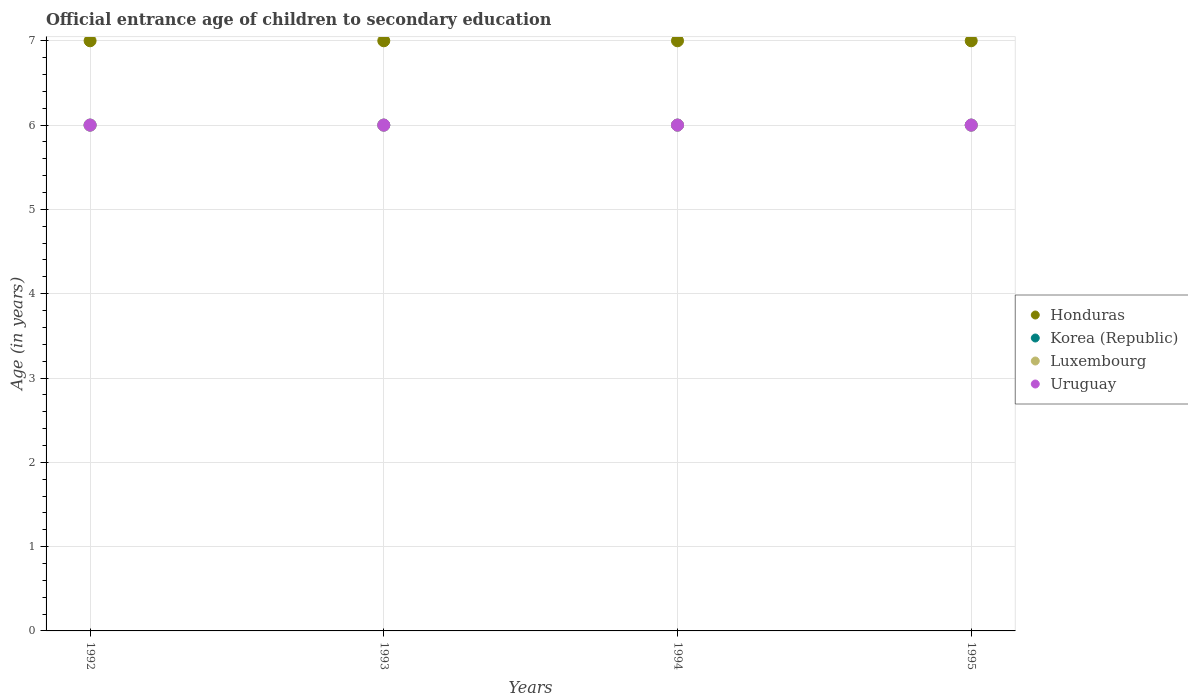How many different coloured dotlines are there?
Your answer should be very brief. 4. What is the secondary school starting age of children in Luxembourg in 1992?
Offer a very short reply. 6. Across all years, what is the maximum secondary school starting age of children in Uruguay?
Make the answer very short. 6. In which year was the secondary school starting age of children in Luxembourg maximum?
Offer a very short reply. 1992. What is the total secondary school starting age of children in Honduras in the graph?
Give a very brief answer. 28. What is the difference between the secondary school starting age of children in Luxembourg in 1992 and that in 1994?
Keep it short and to the point. 0. In the year 1995, what is the difference between the secondary school starting age of children in Korea (Republic) and secondary school starting age of children in Honduras?
Your answer should be compact. -1. In how many years, is the secondary school starting age of children in Uruguay greater than 3.6 years?
Ensure brevity in your answer.  4. Is the secondary school starting age of children in Uruguay in 1993 less than that in 1995?
Provide a short and direct response. No. Is the difference between the secondary school starting age of children in Korea (Republic) in 1993 and 1994 greater than the difference between the secondary school starting age of children in Honduras in 1993 and 1994?
Your answer should be very brief. No. What is the difference between the highest and the second highest secondary school starting age of children in Luxembourg?
Provide a succinct answer. 0. Is the sum of the secondary school starting age of children in Korea (Republic) in 1992 and 1993 greater than the maximum secondary school starting age of children in Uruguay across all years?
Offer a very short reply. Yes. Is it the case that in every year, the sum of the secondary school starting age of children in Uruguay and secondary school starting age of children in Korea (Republic)  is greater than the secondary school starting age of children in Luxembourg?
Your response must be concise. Yes. Does the secondary school starting age of children in Luxembourg monotonically increase over the years?
Your answer should be compact. No. Is the secondary school starting age of children in Korea (Republic) strictly less than the secondary school starting age of children in Uruguay over the years?
Your answer should be compact. No. How many dotlines are there?
Make the answer very short. 4. Are the values on the major ticks of Y-axis written in scientific E-notation?
Give a very brief answer. No. Does the graph contain any zero values?
Make the answer very short. No. How are the legend labels stacked?
Ensure brevity in your answer.  Vertical. What is the title of the graph?
Offer a very short reply. Official entrance age of children to secondary education. What is the label or title of the X-axis?
Ensure brevity in your answer.  Years. What is the label or title of the Y-axis?
Ensure brevity in your answer.  Age (in years). What is the Age (in years) of Uruguay in 1992?
Make the answer very short. 6. What is the Age (in years) in Uruguay in 1994?
Offer a very short reply. 6. What is the Age (in years) in Honduras in 1995?
Provide a succinct answer. 7. What is the Age (in years) in Korea (Republic) in 1995?
Ensure brevity in your answer.  6. What is the Age (in years) in Luxembourg in 1995?
Your response must be concise. 6. Across all years, what is the maximum Age (in years) of Honduras?
Make the answer very short. 7. Across all years, what is the maximum Age (in years) of Luxembourg?
Offer a terse response. 6. Across all years, what is the maximum Age (in years) in Uruguay?
Offer a terse response. 6. Across all years, what is the minimum Age (in years) of Honduras?
Ensure brevity in your answer.  7. Across all years, what is the minimum Age (in years) in Korea (Republic)?
Ensure brevity in your answer.  6. Across all years, what is the minimum Age (in years) in Luxembourg?
Your response must be concise. 6. Across all years, what is the minimum Age (in years) in Uruguay?
Make the answer very short. 6. What is the total Age (in years) in Luxembourg in the graph?
Provide a succinct answer. 24. What is the total Age (in years) of Uruguay in the graph?
Provide a succinct answer. 24. What is the difference between the Age (in years) of Korea (Republic) in 1992 and that in 1993?
Your response must be concise. 0. What is the difference between the Age (in years) in Luxembourg in 1992 and that in 1993?
Keep it short and to the point. 0. What is the difference between the Age (in years) in Uruguay in 1992 and that in 1993?
Ensure brevity in your answer.  0. What is the difference between the Age (in years) of Uruguay in 1992 and that in 1994?
Offer a very short reply. 0. What is the difference between the Age (in years) of Luxembourg in 1992 and that in 1995?
Offer a very short reply. 0. What is the difference between the Age (in years) of Uruguay in 1992 and that in 1995?
Make the answer very short. 0. What is the difference between the Age (in years) of Honduras in 1993 and that in 1994?
Offer a very short reply. 0. What is the difference between the Age (in years) in Luxembourg in 1993 and that in 1994?
Your answer should be compact. 0. What is the difference between the Age (in years) in Uruguay in 1993 and that in 1994?
Ensure brevity in your answer.  0. What is the difference between the Age (in years) of Honduras in 1993 and that in 1995?
Keep it short and to the point. 0. What is the difference between the Age (in years) in Korea (Republic) in 1993 and that in 1995?
Provide a short and direct response. 0. What is the difference between the Age (in years) of Uruguay in 1993 and that in 1995?
Keep it short and to the point. 0. What is the difference between the Age (in years) in Honduras in 1994 and that in 1995?
Offer a terse response. 0. What is the difference between the Age (in years) in Korea (Republic) in 1994 and that in 1995?
Your answer should be very brief. 0. What is the difference between the Age (in years) of Uruguay in 1994 and that in 1995?
Your answer should be very brief. 0. What is the difference between the Age (in years) in Honduras in 1992 and the Age (in years) in Korea (Republic) in 1993?
Ensure brevity in your answer.  1. What is the difference between the Age (in years) in Honduras in 1992 and the Age (in years) in Luxembourg in 1993?
Your answer should be very brief. 1. What is the difference between the Age (in years) of Honduras in 1992 and the Age (in years) of Uruguay in 1993?
Your answer should be compact. 1. What is the difference between the Age (in years) of Korea (Republic) in 1992 and the Age (in years) of Luxembourg in 1993?
Make the answer very short. 0. What is the difference between the Age (in years) of Korea (Republic) in 1992 and the Age (in years) of Uruguay in 1993?
Provide a short and direct response. 0. What is the difference between the Age (in years) in Honduras in 1992 and the Age (in years) in Korea (Republic) in 1994?
Your answer should be compact. 1. What is the difference between the Age (in years) in Honduras in 1992 and the Age (in years) in Luxembourg in 1994?
Provide a succinct answer. 1. What is the difference between the Age (in years) in Korea (Republic) in 1992 and the Age (in years) in Uruguay in 1994?
Provide a short and direct response. 0. What is the difference between the Age (in years) in Honduras in 1992 and the Age (in years) in Korea (Republic) in 1995?
Your answer should be compact. 1. What is the difference between the Age (in years) in Honduras in 1992 and the Age (in years) in Luxembourg in 1995?
Ensure brevity in your answer.  1. What is the difference between the Age (in years) of Honduras in 1992 and the Age (in years) of Uruguay in 1995?
Make the answer very short. 1. What is the difference between the Age (in years) in Korea (Republic) in 1992 and the Age (in years) in Uruguay in 1995?
Your answer should be very brief. 0. What is the difference between the Age (in years) of Luxembourg in 1992 and the Age (in years) of Uruguay in 1995?
Ensure brevity in your answer.  0. What is the difference between the Age (in years) in Honduras in 1993 and the Age (in years) in Luxembourg in 1994?
Keep it short and to the point. 1. What is the difference between the Age (in years) in Honduras in 1993 and the Age (in years) in Uruguay in 1994?
Make the answer very short. 1. What is the difference between the Age (in years) in Korea (Republic) in 1993 and the Age (in years) in Luxembourg in 1994?
Keep it short and to the point. 0. What is the difference between the Age (in years) of Korea (Republic) in 1993 and the Age (in years) of Uruguay in 1994?
Make the answer very short. 0. What is the difference between the Age (in years) of Honduras in 1993 and the Age (in years) of Korea (Republic) in 1995?
Provide a short and direct response. 1. What is the difference between the Age (in years) in Honduras in 1993 and the Age (in years) in Luxembourg in 1995?
Keep it short and to the point. 1. What is the difference between the Age (in years) of Korea (Republic) in 1993 and the Age (in years) of Uruguay in 1995?
Your answer should be compact. 0. What is the difference between the Age (in years) in Honduras in 1994 and the Age (in years) in Korea (Republic) in 1995?
Make the answer very short. 1. What is the difference between the Age (in years) of Honduras in 1994 and the Age (in years) of Luxembourg in 1995?
Your answer should be very brief. 1. What is the difference between the Age (in years) in Luxembourg in 1994 and the Age (in years) in Uruguay in 1995?
Keep it short and to the point. 0. What is the average Age (in years) of Honduras per year?
Provide a succinct answer. 7. What is the average Age (in years) in Korea (Republic) per year?
Your response must be concise. 6. What is the average Age (in years) in Uruguay per year?
Your response must be concise. 6. In the year 1992, what is the difference between the Age (in years) of Korea (Republic) and Age (in years) of Uruguay?
Give a very brief answer. 0. In the year 1992, what is the difference between the Age (in years) of Luxembourg and Age (in years) of Uruguay?
Ensure brevity in your answer.  0. In the year 1993, what is the difference between the Age (in years) in Honduras and Age (in years) in Luxembourg?
Your response must be concise. 1. In the year 1993, what is the difference between the Age (in years) of Honduras and Age (in years) of Uruguay?
Provide a short and direct response. 1. In the year 1993, what is the difference between the Age (in years) in Korea (Republic) and Age (in years) in Luxembourg?
Give a very brief answer. 0. In the year 1993, what is the difference between the Age (in years) in Luxembourg and Age (in years) in Uruguay?
Your answer should be very brief. 0. In the year 1994, what is the difference between the Age (in years) in Honduras and Age (in years) in Uruguay?
Make the answer very short. 1. In the year 1994, what is the difference between the Age (in years) in Korea (Republic) and Age (in years) in Luxembourg?
Provide a short and direct response. 0. In the year 1994, what is the difference between the Age (in years) of Korea (Republic) and Age (in years) of Uruguay?
Keep it short and to the point. 0. In the year 1994, what is the difference between the Age (in years) in Luxembourg and Age (in years) in Uruguay?
Your response must be concise. 0. In the year 1995, what is the difference between the Age (in years) in Honduras and Age (in years) in Luxembourg?
Your answer should be very brief. 1. In the year 1995, what is the difference between the Age (in years) of Honduras and Age (in years) of Uruguay?
Provide a short and direct response. 1. In the year 1995, what is the difference between the Age (in years) of Luxembourg and Age (in years) of Uruguay?
Your answer should be compact. 0. What is the ratio of the Age (in years) of Honduras in 1992 to that in 1993?
Give a very brief answer. 1. What is the ratio of the Age (in years) of Honduras in 1992 to that in 1995?
Provide a succinct answer. 1. What is the ratio of the Age (in years) of Luxembourg in 1992 to that in 1995?
Provide a succinct answer. 1. What is the ratio of the Age (in years) in Uruguay in 1992 to that in 1995?
Provide a succinct answer. 1. What is the ratio of the Age (in years) of Korea (Republic) in 1993 to that in 1994?
Offer a terse response. 1. What is the ratio of the Age (in years) in Luxembourg in 1993 to that in 1994?
Provide a succinct answer. 1. What is the ratio of the Age (in years) in Uruguay in 1993 to that in 1994?
Offer a very short reply. 1. What is the ratio of the Age (in years) in Luxembourg in 1994 to that in 1995?
Your answer should be very brief. 1. What is the ratio of the Age (in years) in Uruguay in 1994 to that in 1995?
Make the answer very short. 1. What is the difference between the highest and the second highest Age (in years) of Honduras?
Your answer should be compact. 0. What is the difference between the highest and the second highest Age (in years) in Korea (Republic)?
Provide a short and direct response. 0. What is the difference between the highest and the second highest Age (in years) in Uruguay?
Give a very brief answer. 0. What is the difference between the highest and the lowest Age (in years) in Korea (Republic)?
Your answer should be compact. 0. What is the difference between the highest and the lowest Age (in years) in Uruguay?
Provide a succinct answer. 0. 